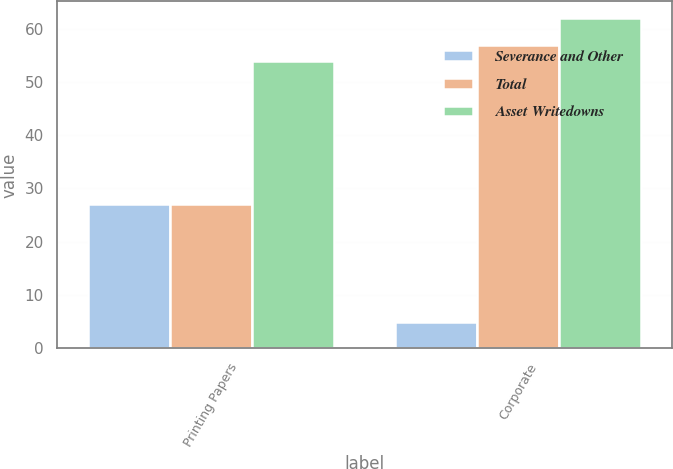Convert chart to OTSL. <chart><loc_0><loc_0><loc_500><loc_500><stacked_bar_chart><ecel><fcel>Printing Papers<fcel>Corporate<nl><fcel>Severance and Other<fcel>27<fcel>5<nl><fcel>Total<fcel>27<fcel>57<nl><fcel>Asset Writedowns<fcel>54<fcel>62<nl></chart> 